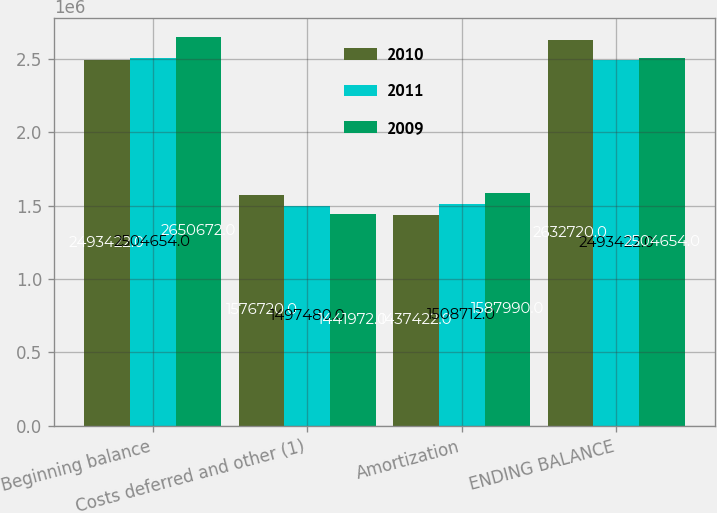<chart> <loc_0><loc_0><loc_500><loc_500><stacked_bar_chart><ecel><fcel>Beginning balance<fcel>Costs deferred and other (1)<fcel>Amortization<fcel>ENDING BALANCE<nl><fcel>2010<fcel>2.49342e+06<fcel>1.57672e+06<fcel>1.43742e+06<fcel>2.63272e+06<nl><fcel>2011<fcel>2.50465e+06<fcel>1.49748e+06<fcel>1.50871e+06<fcel>2.49342e+06<nl><fcel>2009<fcel>2.65067e+06<fcel>1.44197e+06<fcel>1.58799e+06<fcel>2.50465e+06<nl></chart> 